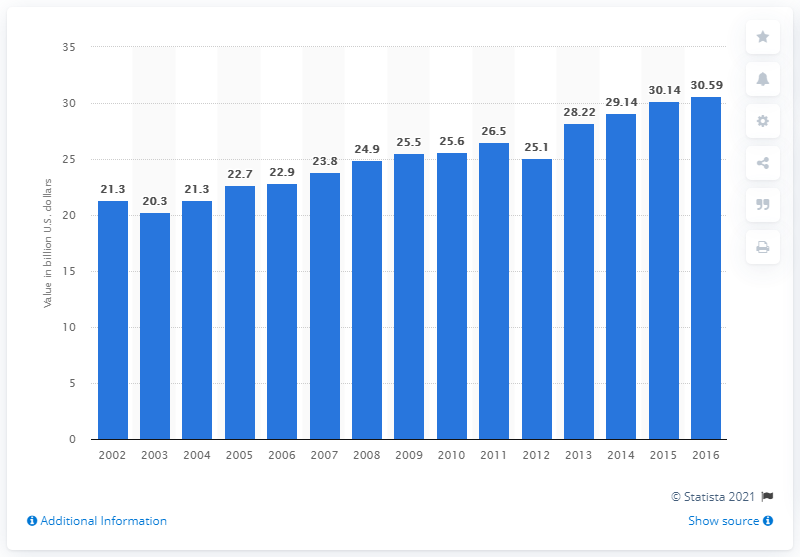Outline some significant characteristics in this image. The value of commercial bakery products in the United States in 2016 was approximately 30.59 billion dollars. 